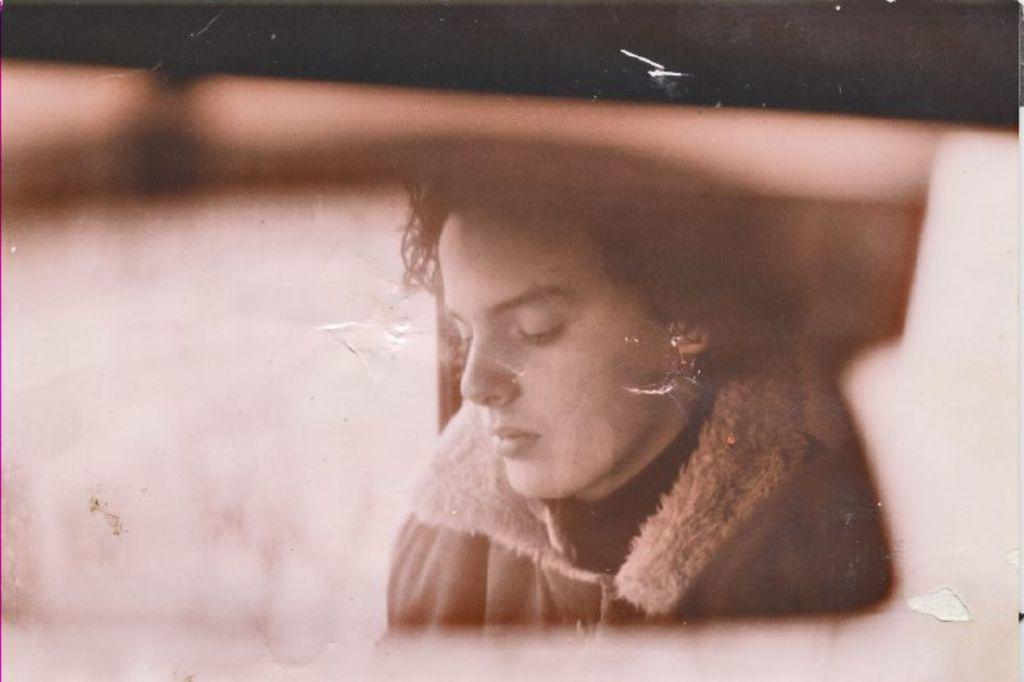Who or what is the main subject of the image? There is a person in the image. What is the person wearing in the image? The person is wearing a jacket. Can you describe the background of the image? The background of the image is in black and brown color. How is the image presented in terms of color? The image is in black and white. How many chairs are visible in the image? There are no chairs present in the image; it features a person wearing a jacket against a black and brown background. 